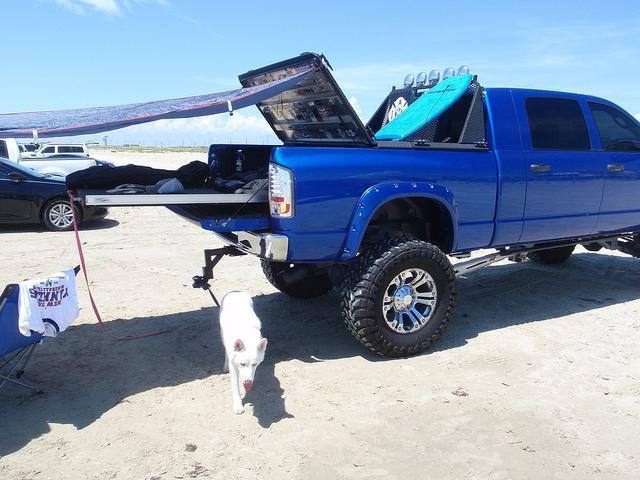How many people are on the TV screen?
Give a very brief answer. 0. 